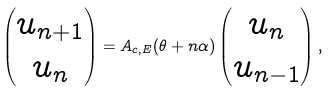Convert formula to latex. <formula><loc_0><loc_0><loc_500><loc_500>\left ( \begin{matrix} u _ { n + 1 } \\ u _ { n } \end{matrix} \right ) = A _ { c , E } ( \theta + n \alpha ) \left ( \begin{matrix} u _ { n } \\ u _ { n - 1 } \end{matrix} \right ) ,</formula> 